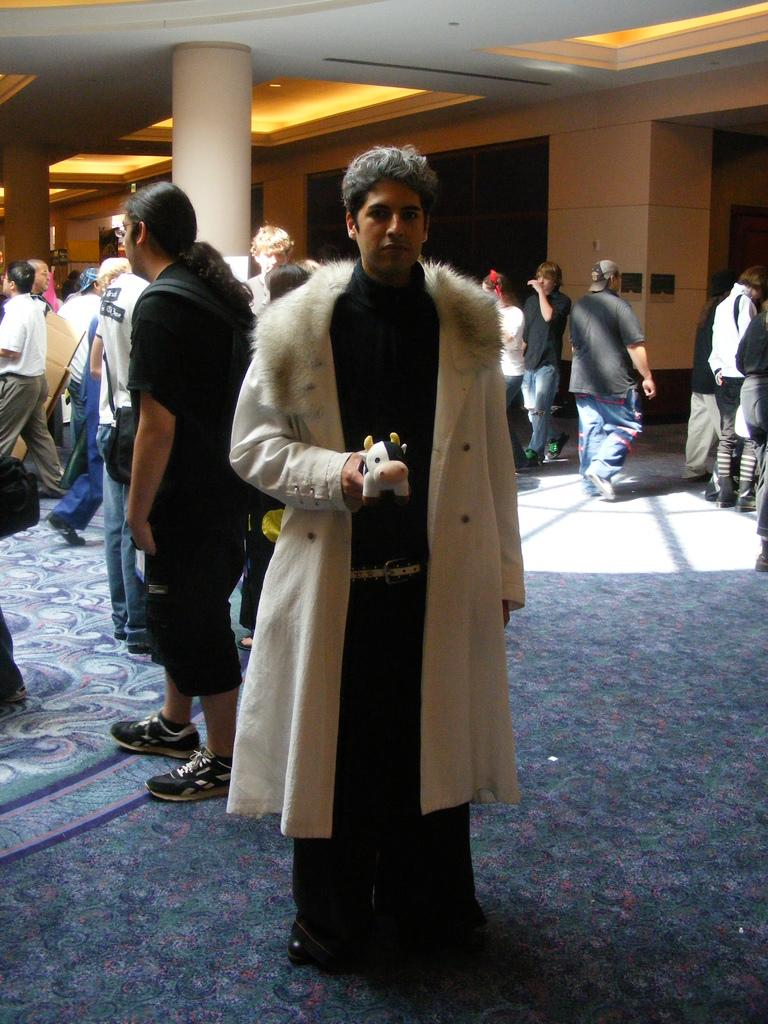What is the main subject of the image? There is a person standing in the center of the image. What is the person standing on? The person is standing on the ground. Can you describe the background of the image? There are persons, a pillar, lights, and a wall in the background of the image. What is the condition of the nation in the image? There is no reference to a nation or its condition in the image. The image only shows a person standing on the ground with a background containing other persons, a pillar, lights, and a wall. 